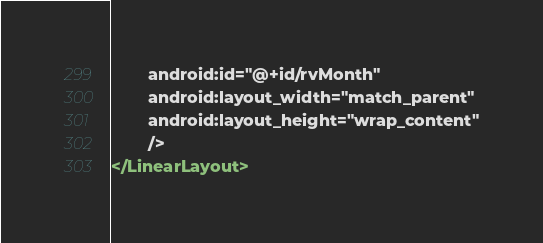<code> <loc_0><loc_0><loc_500><loc_500><_XML_>        android:id="@+id/rvMonth"
        android:layout_width="match_parent"
        android:layout_height="wrap_content"
        />
</LinearLayout>
</code> 